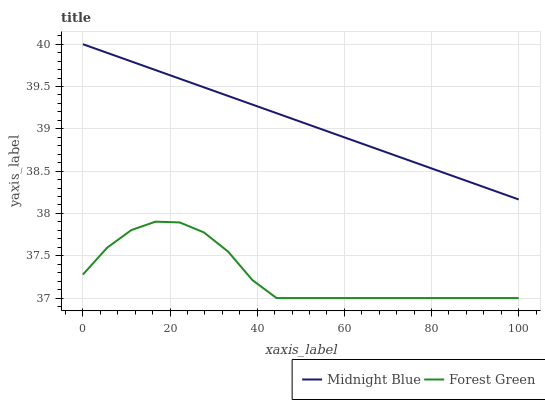Does Forest Green have the minimum area under the curve?
Answer yes or no. Yes. Does Midnight Blue have the maximum area under the curve?
Answer yes or no. Yes. Does Midnight Blue have the minimum area under the curve?
Answer yes or no. No. Is Midnight Blue the smoothest?
Answer yes or no. Yes. Is Forest Green the roughest?
Answer yes or no. Yes. Is Midnight Blue the roughest?
Answer yes or no. No. Does Forest Green have the lowest value?
Answer yes or no. Yes. Does Midnight Blue have the lowest value?
Answer yes or no. No. Does Midnight Blue have the highest value?
Answer yes or no. Yes. Is Forest Green less than Midnight Blue?
Answer yes or no. Yes. Is Midnight Blue greater than Forest Green?
Answer yes or no. Yes. Does Forest Green intersect Midnight Blue?
Answer yes or no. No. 